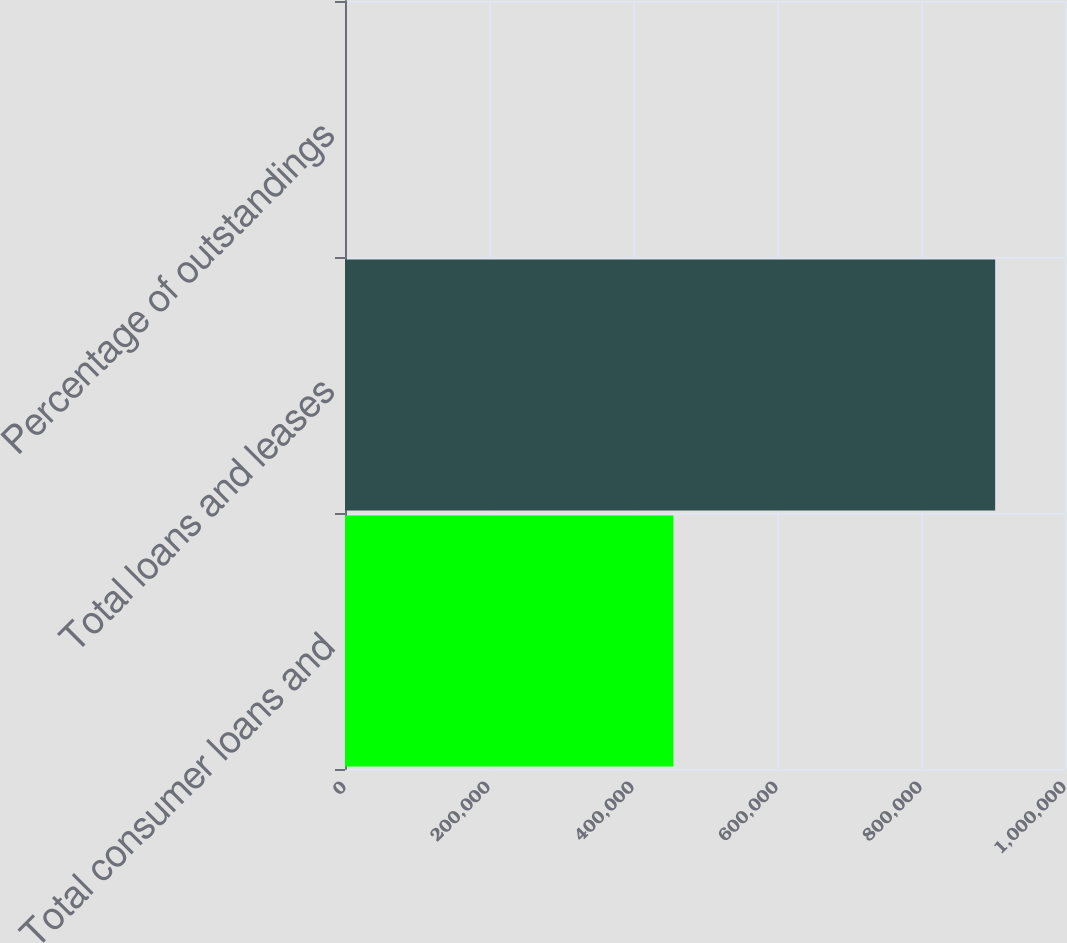<chart> <loc_0><loc_0><loc_500><loc_500><bar_chart><fcel>Total consumer loans and<fcel>Total loans and leases<fcel>Percentage of outstandings<nl><fcel>456169<fcel>903001<fcel>100<nl></chart> 